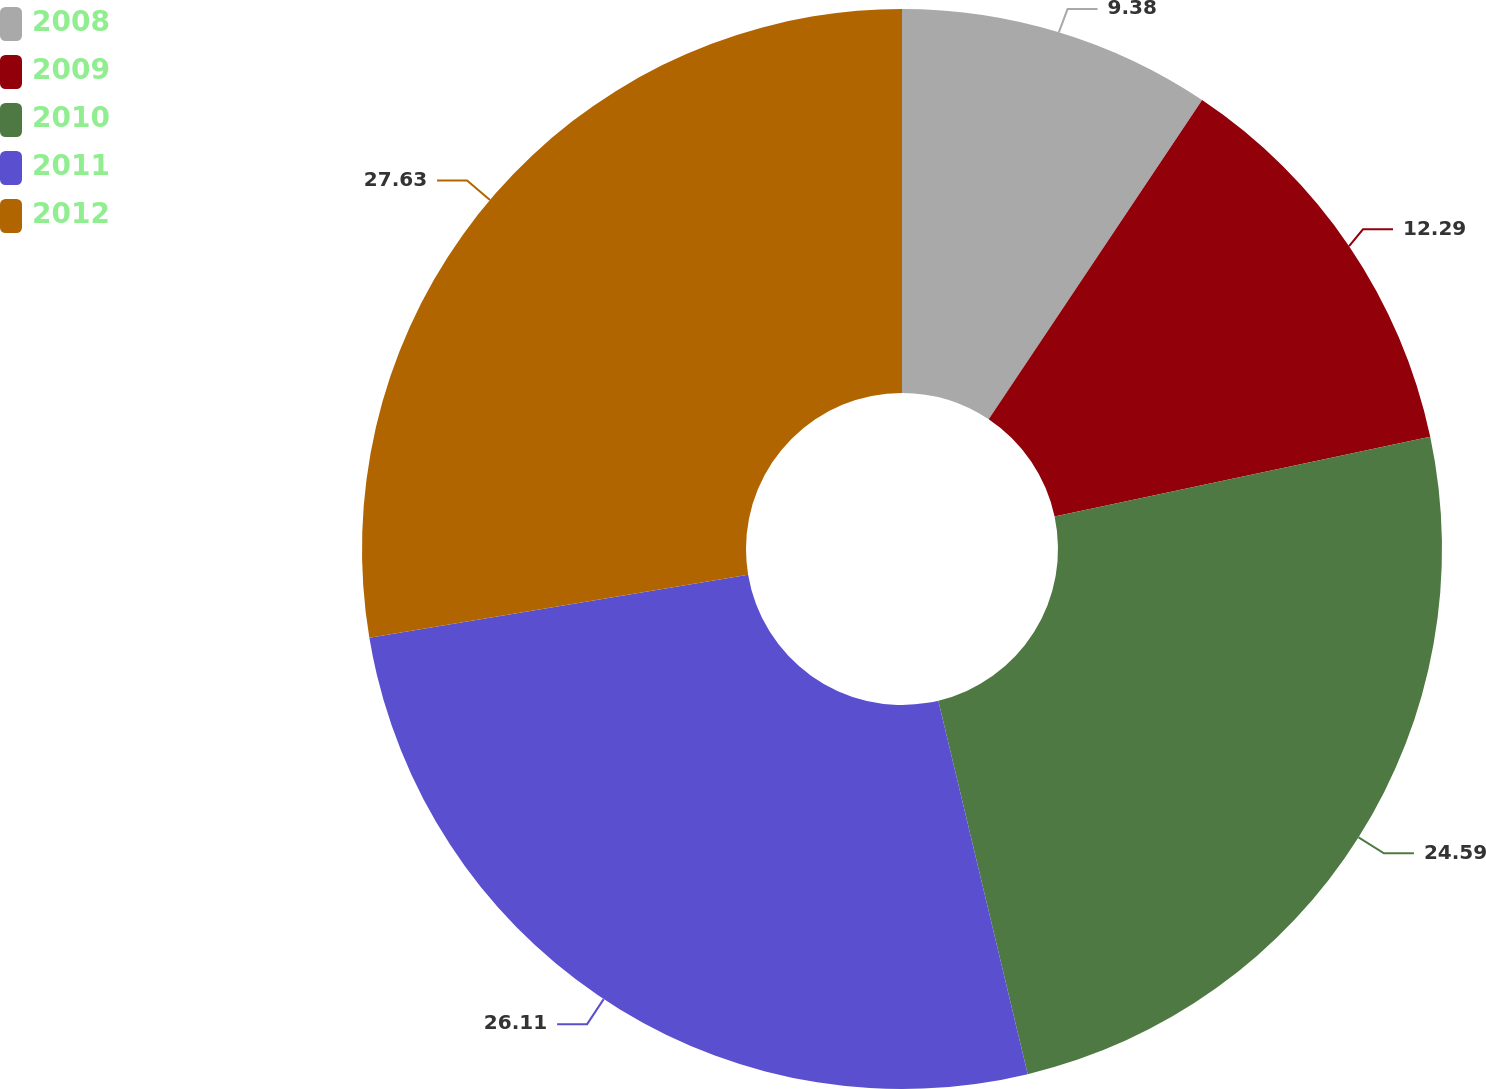<chart> <loc_0><loc_0><loc_500><loc_500><pie_chart><fcel>2008<fcel>2009<fcel>2010<fcel>2011<fcel>2012<nl><fcel>9.38%<fcel>12.29%<fcel>24.59%<fcel>26.11%<fcel>27.63%<nl></chart> 